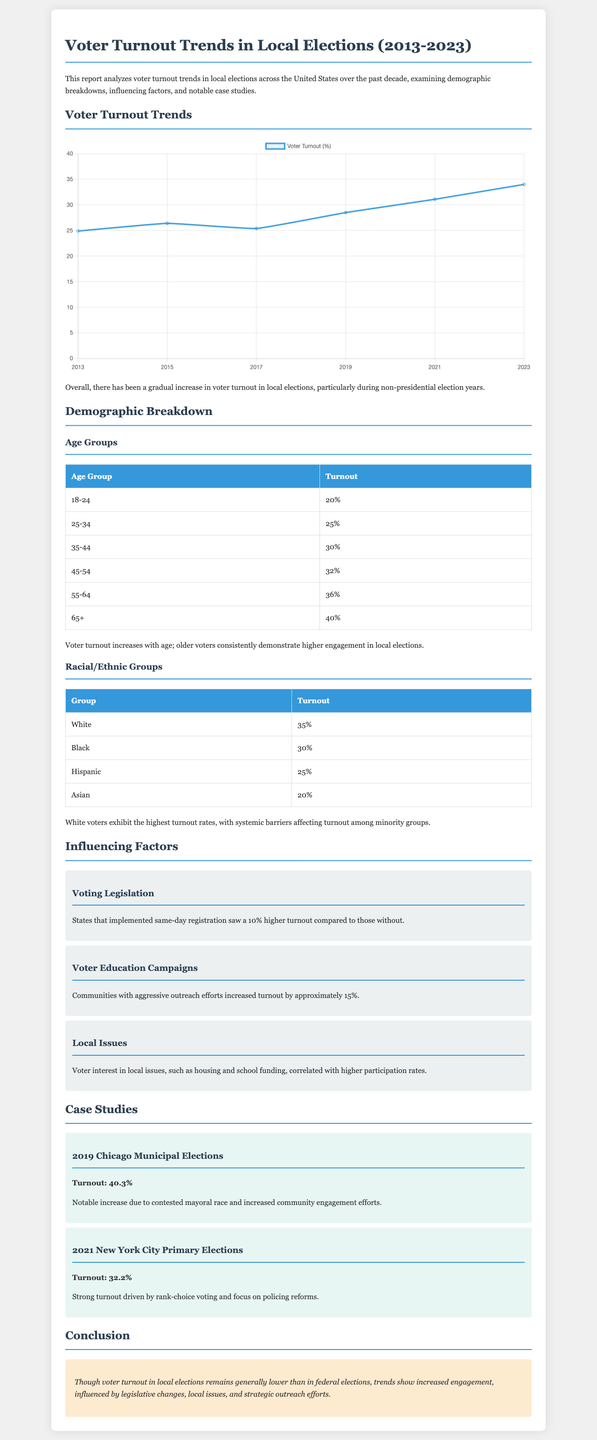What was the voter turnout in 2019? The document lists the turnout for the 2019 Chicago Municipal Elections as 40.3%.
Answer: 40.3% What age group has the highest turnout? According to the demographic breakdown, the age group 65+ has the highest turnout rate.
Answer: 65+ What is the turnout percentage for Asian voters? The document states that the turnout for Asian voters is 20%.
Answer: 20% What was the turnout percentage in 2023? The report mentions that the voter turnout in 2023 was 34.0%.
Answer: 34.0% How much higher was turnout in states with same-day registration? The document indicates that states with same-day registration saw a 10% higher turnout.
Answer: 10% Which local elections had a turnout of 32.2%? The document specifies that the 2021 New York City Primary Elections had a turnout of 32.2%.
Answer: 2021 New York City Primary Elections What factor is associated with a 15% increase in turnout? The report mentions that voter education campaigns are associated with a 15% increase in turnout.
Answer: Voter Education Campaigns Which demographic group showed the lowest turnout? The document indicates that the Asian demographic group showed the lowest voter turnout.
Answer: Asian What is the main trend observed in voter turnout over the last decade? The report notes a gradual increase in voter turnout over the last decade.
Answer: Gradual increase 